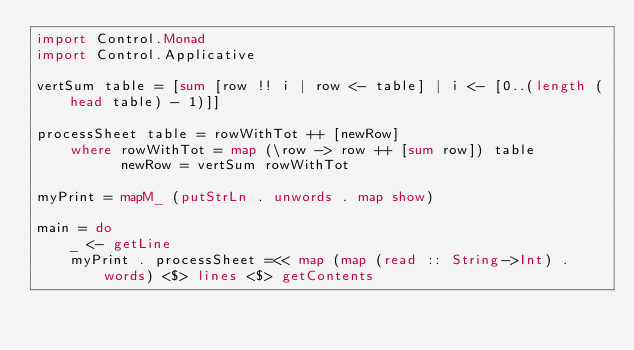<code> <loc_0><loc_0><loc_500><loc_500><_Haskell_>import Control.Monad
import Control.Applicative

vertSum table = [sum [row !! i | row <- table] | i <- [0..(length (head table) - 1)]]

processSheet table = rowWithTot ++ [newRow]
    where rowWithTot = map (\row -> row ++ [sum row]) table
          newRow = vertSum rowWithTot

myPrint = mapM_ (putStrLn . unwords . map show)

main = do
    _ <- getLine
    myPrint . processSheet =<< map (map (read :: String->Int) . words) <$> lines <$> getContents</code> 